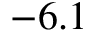Convert formula to latex. <formula><loc_0><loc_0><loc_500><loc_500>- 6 . 1</formula> 